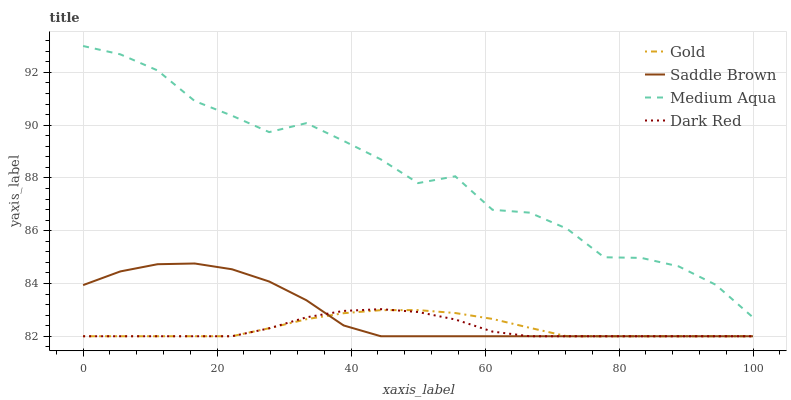Does Dark Red have the minimum area under the curve?
Answer yes or no. Yes. Does Medium Aqua have the maximum area under the curve?
Answer yes or no. Yes. Does Saddle Brown have the minimum area under the curve?
Answer yes or no. No. Does Saddle Brown have the maximum area under the curve?
Answer yes or no. No. Is Gold the smoothest?
Answer yes or no. Yes. Is Medium Aqua the roughest?
Answer yes or no. Yes. Is Saddle Brown the smoothest?
Answer yes or no. No. Is Saddle Brown the roughest?
Answer yes or no. No. Does Medium Aqua have the lowest value?
Answer yes or no. No. Does Medium Aqua have the highest value?
Answer yes or no. Yes. Does Saddle Brown have the highest value?
Answer yes or no. No. Is Gold less than Medium Aqua?
Answer yes or no. Yes. Is Medium Aqua greater than Gold?
Answer yes or no. Yes. Does Saddle Brown intersect Gold?
Answer yes or no. Yes. Is Saddle Brown less than Gold?
Answer yes or no. No. Is Saddle Brown greater than Gold?
Answer yes or no. No. Does Gold intersect Medium Aqua?
Answer yes or no. No. 